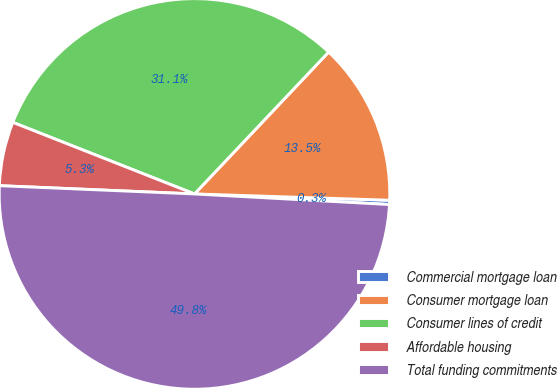Convert chart. <chart><loc_0><loc_0><loc_500><loc_500><pie_chart><fcel>Commercial mortgage loan<fcel>Consumer mortgage loan<fcel>Consumer lines of credit<fcel>Affordable housing<fcel>Total funding commitments<nl><fcel>0.35%<fcel>13.46%<fcel>31.08%<fcel>5.3%<fcel>49.81%<nl></chart> 